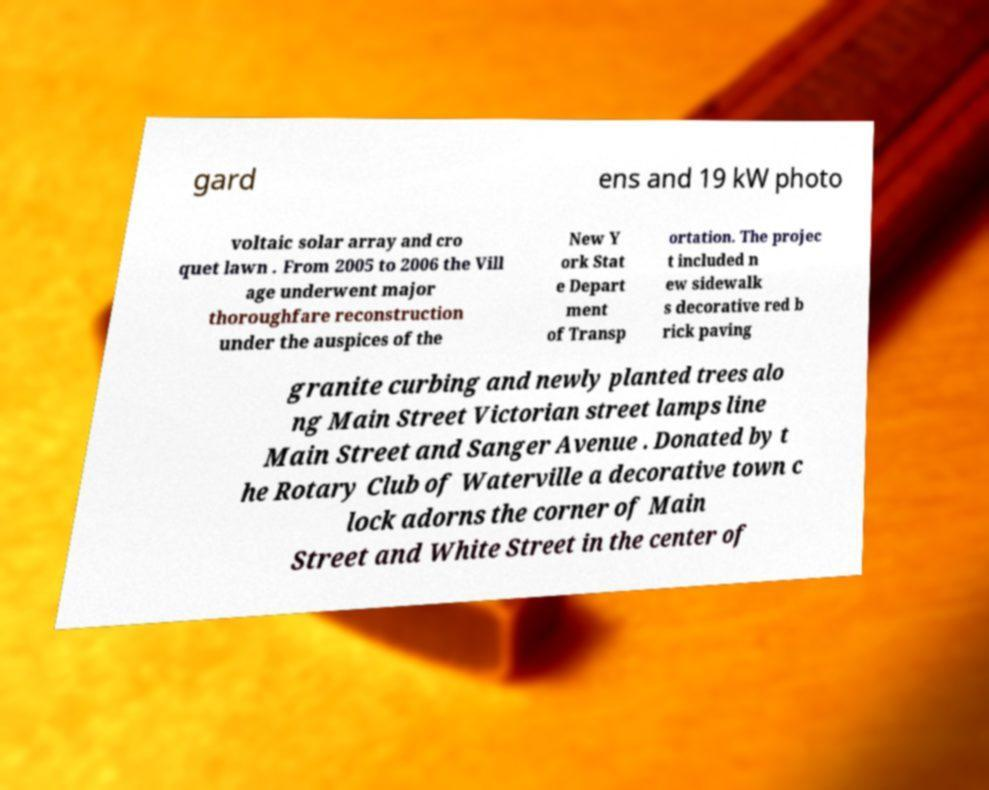There's text embedded in this image that I need extracted. Can you transcribe it verbatim? gard ens and 19 kW photo voltaic solar array and cro quet lawn . From 2005 to 2006 the Vill age underwent major thoroughfare reconstruction under the auspices of the New Y ork Stat e Depart ment of Transp ortation. The projec t included n ew sidewalk s decorative red b rick paving granite curbing and newly planted trees alo ng Main Street Victorian street lamps line Main Street and Sanger Avenue . Donated by t he Rotary Club of Waterville a decorative town c lock adorns the corner of Main Street and White Street in the center of 